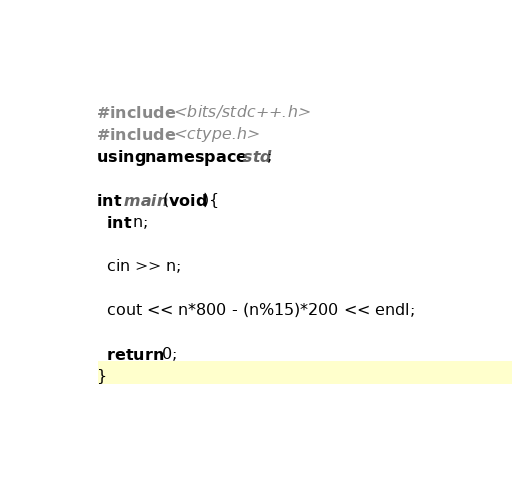Convert code to text. <code><loc_0><loc_0><loc_500><loc_500><_C++_>#include <bits/stdc++.h>
#include <ctype.h>
using namespace std;

int main(void){
  int n;

  cin >> n;

  cout << n*800 - (n%15)*200 << endl;

  return 0;
}</code> 